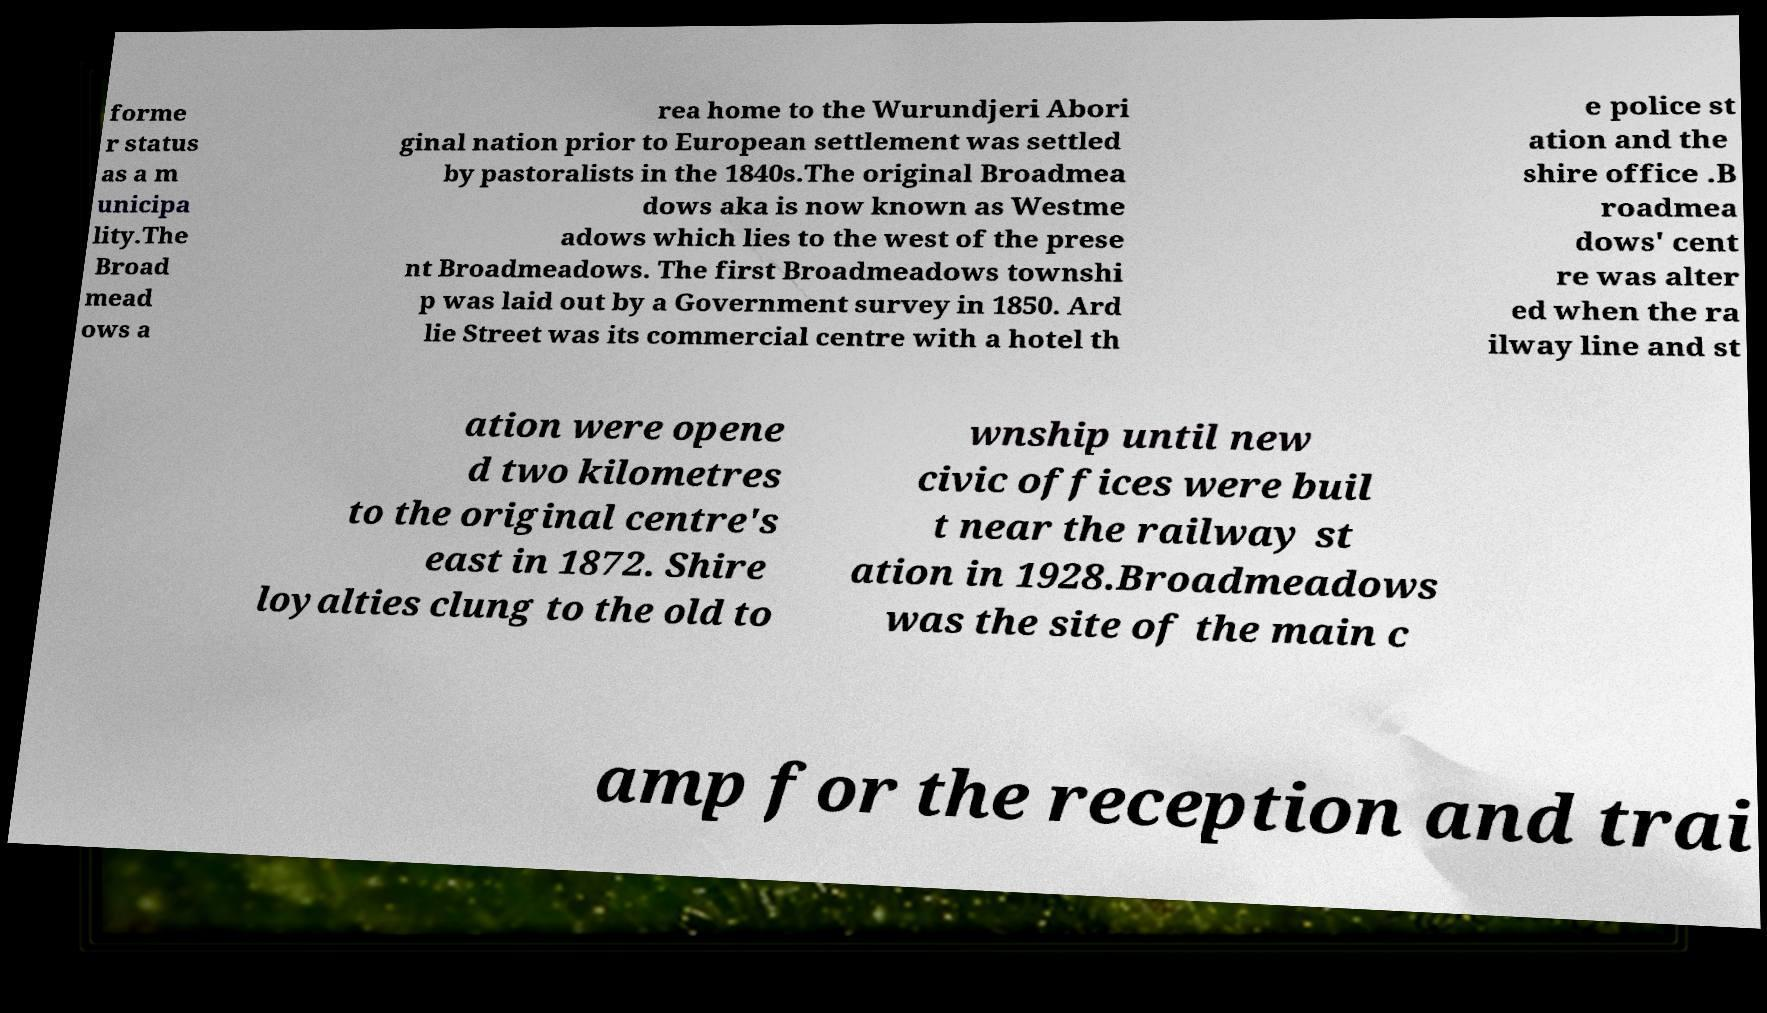Please identify and transcribe the text found in this image. forme r status as a m unicipa lity.The Broad mead ows a rea home to the Wurundjeri Abori ginal nation prior to European settlement was settled by pastoralists in the 1840s.The original Broadmea dows aka is now known as Westme adows which lies to the west of the prese nt Broadmeadows. The first Broadmeadows townshi p was laid out by a Government survey in 1850. Ard lie Street was its commercial centre with a hotel th e police st ation and the shire office .B roadmea dows' cent re was alter ed when the ra ilway line and st ation were opene d two kilometres to the original centre's east in 1872. Shire loyalties clung to the old to wnship until new civic offices were buil t near the railway st ation in 1928.Broadmeadows was the site of the main c amp for the reception and trai 